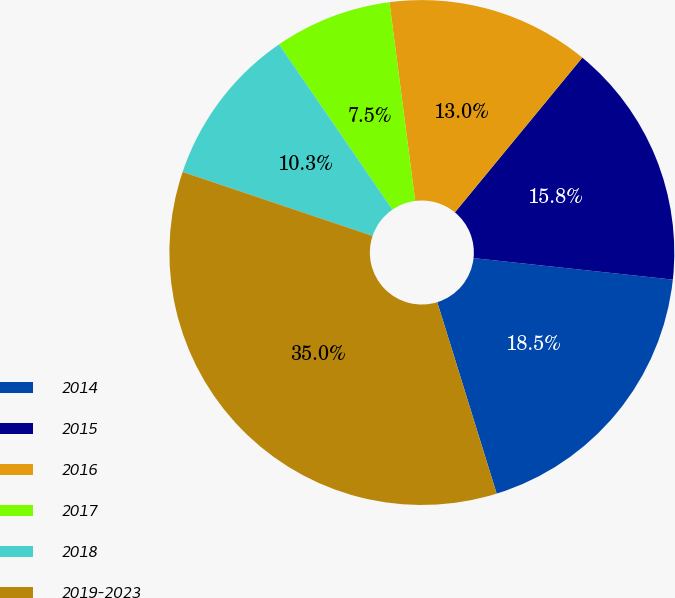Convert chart. <chart><loc_0><loc_0><loc_500><loc_500><pie_chart><fcel>2014<fcel>2015<fcel>2016<fcel>2017<fcel>2018<fcel>2019-2023<nl><fcel>18.5%<fcel>15.75%<fcel>13.01%<fcel>7.52%<fcel>10.26%<fcel>34.96%<nl></chart> 